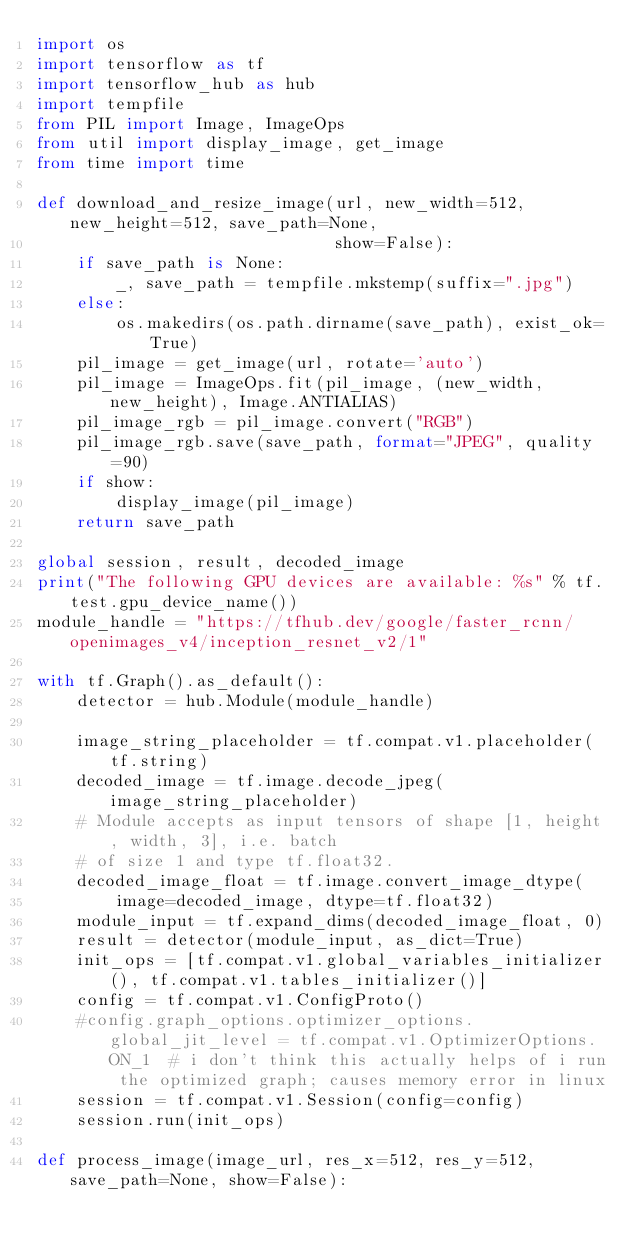<code> <loc_0><loc_0><loc_500><loc_500><_Python_>import os
import tensorflow as tf
import tensorflow_hub as hub
import tempfile
from PIL import Image, ImageOps
from util import display_image, get_image
from time import time

def download_and_resize_image(url, new_width=512, new_height=512, save_path=None,
                              show=False):
    if save_path is None:
        _, save_path = tempfile.mkstemp(suffix=".jpg")
    else:
        os.makedirs(os.path.dirname(save_path), exist_ok=True)
    pil_image = get_image(url, rotate='auto')
    pil_image = ImageOps.fit(pil_image, (new_width, new_height), Image.ANTIALIAS)
    pil_image_rgb = pil_image.convert("RGB")
    pil_image_rgb.save(save_path, format="JPEG", quality=90)
    if show:
        display_image(pil_image)
    return save_path

global session, result, decoded_image
print("The following GPU devices are available: %s" % tf.test.gpu_device_name())
module_handle = "https://tfhub.dev/google/faster_rcnn/openimages_v4/inception_resnet_v2/1"

with tf.Graph().as_default():
    detector = hub.Module(module_handle)

    image_string_placeholder = tf.compat.v1.placeholder(tf.string)
    decoded_image = tf.image.decode_jpeg(image_string_placeholder)
    # Module accepts as input tensors of shape [1, height, width, 3], i.e. batch
    # of size 1 and type tf.float32.
    decoded_image_float = tf.image.convert_image_dtype(
        image=decoded_image, dtype=tf.float32)
    module_input = tf.expand_dims(decoded_image_float, 0)
    result = detector(module_input, as_dict=True)
    init_ops = [tf.compat.v1.global_variables_initializer(), tf.compat.v1.tables_initializer()]
    config = tf.compat.v1.ConfigProto()
    #config.graph_options.optimizer_options.global_jit_level = tf.compat.v1.OptimizerOptions.ON_1  # i don't think this actually helps of i run the optimized graph; causes memory error in linux
    session = tf.compat.v1.Session(config=config)
    session.run(init_ops)

def process_image(image_url, res_x=512, res_y=512, save_path=None, show=False):</code> 